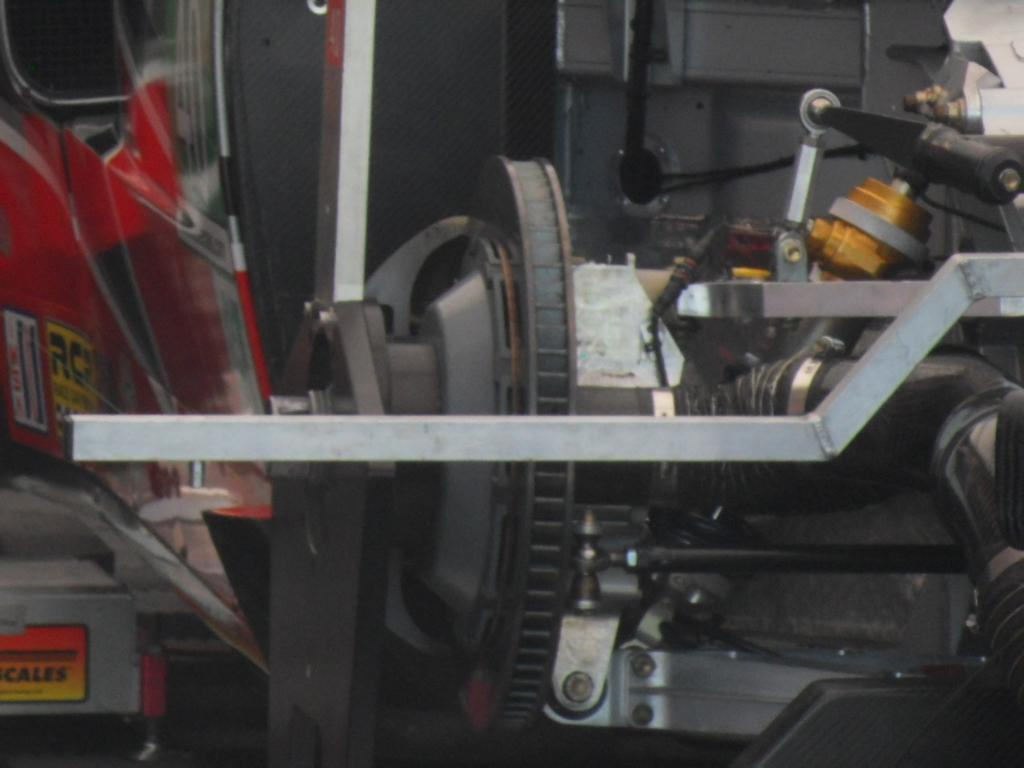What type of objects can be seen in the image? There are rods and a motor in the image. What material are the objects made of? The objects are made of metal. What type of frog can be seen playing with the toys in the image? There are no frogs or toys present in the image; it only features rods and a motor. 